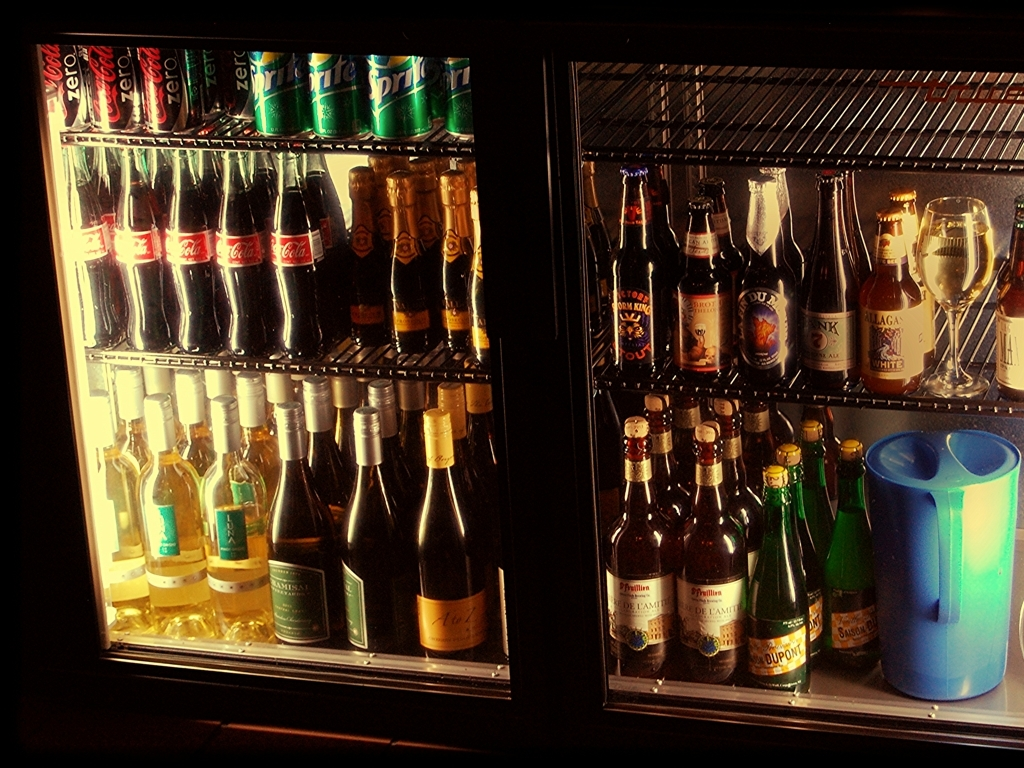Are the details of the main subject rich in texture? Yes, the main subject, which includes a variety of beverages in a fridge, shows a rich texture. The labels, bottle surfaces, and condensation offer a diverse range of textures that are clearly visible and provide depth to the image. 